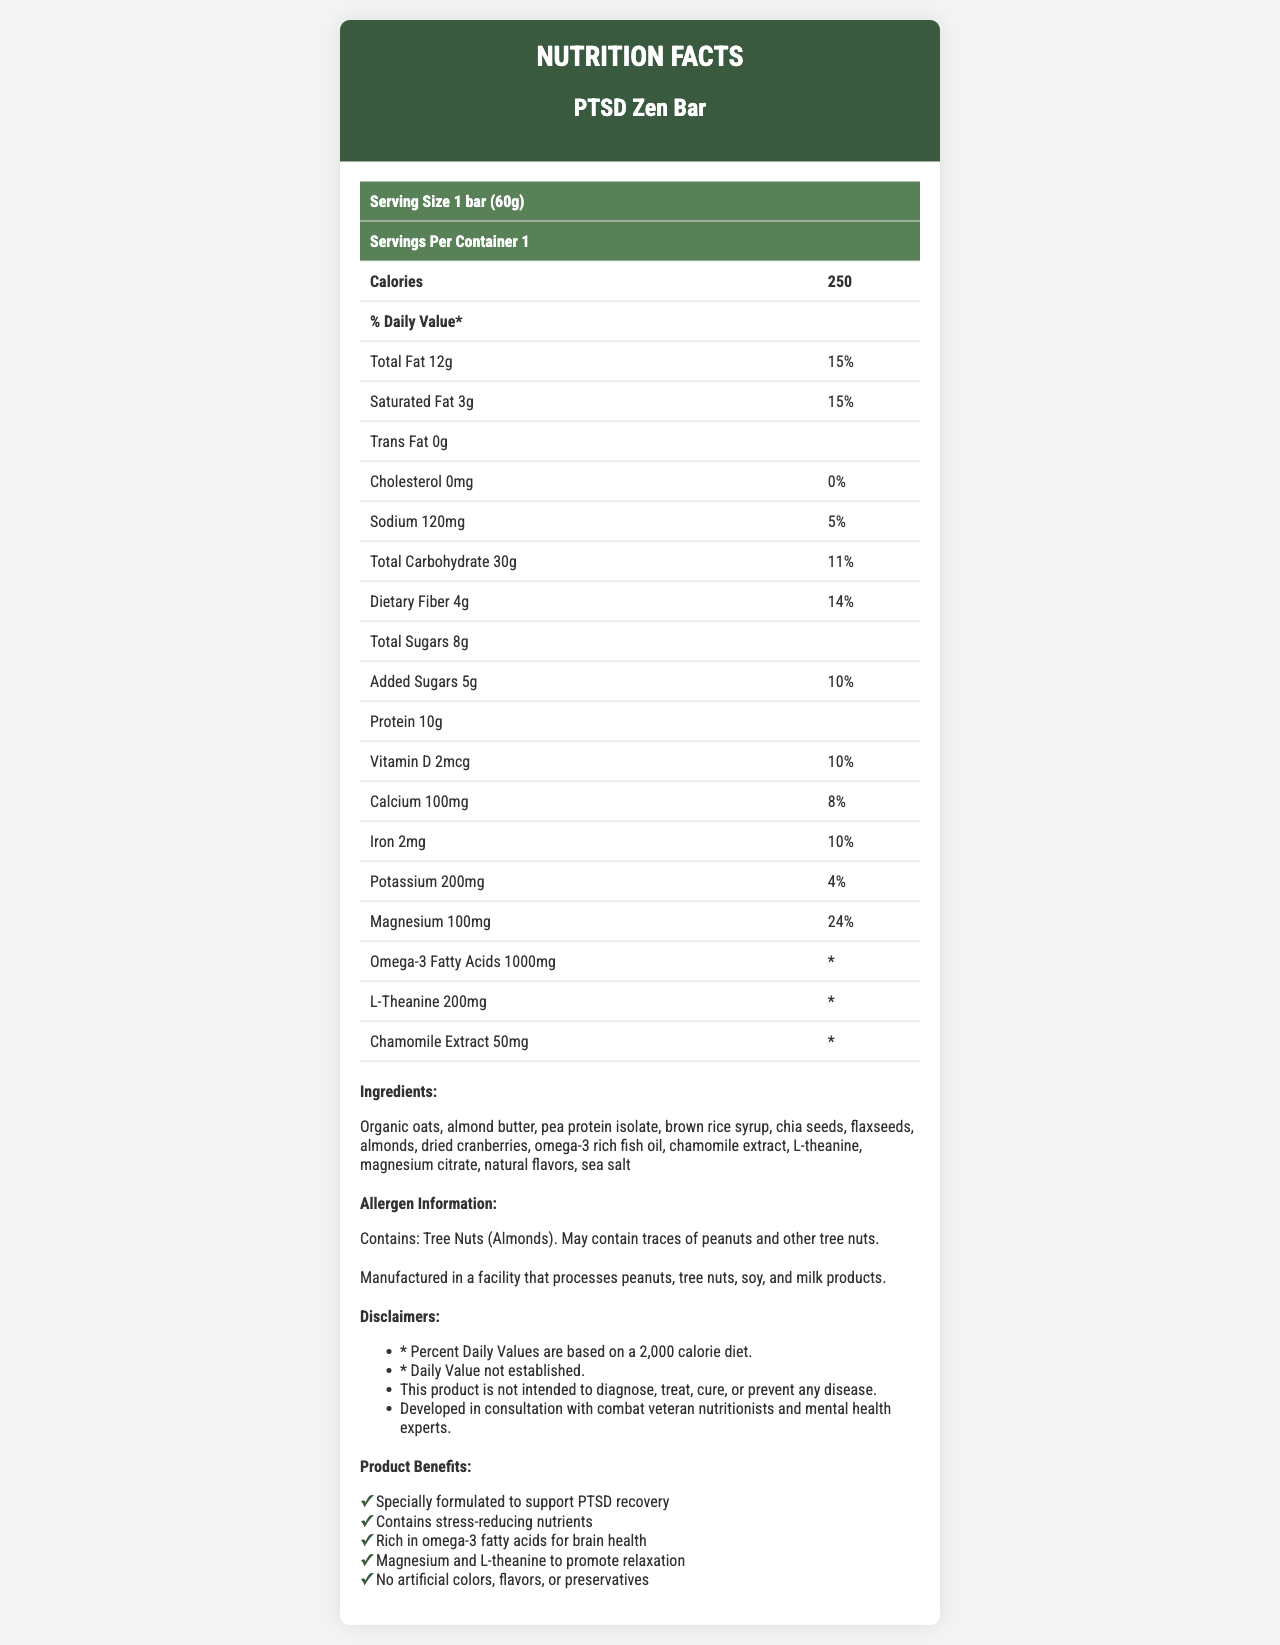what is the serving size of the PTSD Zen Bar? The serving size is explicitly stated as '1 bar (60g)' at the top of the Nutrition Facts table.
Answer: 1 bar (60g) how many calories are in one serving of the PTSD Zen Bar? The number of calories per serving is clearly mentioned as '250' in the document.
Answer: 250 calories which vitamin does the PTSD Zen Bar provide 10% of the daily value? The document lists Vitamin D with an amount of '2mcg', also providing '10%' of the daily value.
Answer: Vitamin D What are the two main ingredients in the PTSD Zen Bar? The ingredients list begins with 'Organic oats, almond butter,' indicating they are the main ingredients.
Answer: Organic oats and almond butter does the PTSD Zen Bar contain any cholesterol? The cholesterol amount is listed as '0mg', with a '0%' daily value, indicating there is no cholesterol in the product.
Answer: No what specific allergens does the PTSD Zen Bar contain? The allergen information explicitly states 'Contains: Tree Nuts (Almonds)'.
Answer: Tree Nuts (Almonds) how much protein is in one serving of the PTSD Zen Bar? The protein content is listed as '10g' in the Nutrition Facts.
Answer: 10g which nutrient is present in the highest quantity relative to its daily value percentage? A. Magnesium B. Calcium C. Iron D. Omega-3 Fatty Acids Magnesium is shown to be at '24%' of the daily value, which is higher than Calcium ('8%') and Iron ('10%'). Omega-3 Fatty Acids do not have a daily value percentage established.
Answer: A. Magnesium which of the following is NOT a benefit claimed by the PTSD Zen Bar? 1) Contains stress-reducing nutrients 2) Promotes General Energy Increase 3) Rich in omega-3 fatty acids for brain health The listed benefits include stress-reducing nutrients and omega-3 fatty acids for brain health, but 'Promotes General Energy Increase' is not mentioned.
Answer: 2) Promotes General Energy Increase Is the PTSD Zen Bar suitable for people with peanut allergies? The document mentions that it 'May contain traces of peanuts', indicating a risk for people with peanut allergies.
Answer: Not necessarily Summarize the main claims and nutritional information of the PTSD Zen Bar. The document includes comprehensive details about the bar's ingredients and nutritional value, marketing it as a product that promotes brain health and relaxation, particularly targeting those recovering from PTSD.
Answer: The PTSD Zen Bar is designed to support PTSD recovery with stress-reducing nutrients and contains organic oats, almond butter, and other beneficial ingredients. It provides 250 calories per serving, with key nutrients like 12g of fat, 30g of carbohydrates, 10g of protein, and significant amounts of magnesium and omega-3 fatty acids. The bar also contains chamomile extract and L-theanine to promote relaxation. How much Omega-3 fatty acids are present in the PTSD Zen Bar? The amount of Omega-3 fatty acids is explicitly listed as '1000mg' in the document.
Answer: 1000mg who were consulted in the development of the PTSD Zen Bar? The manufacturer’s statement confirms that the product was developed in consultation with combat veteran nutritionists and mental health experts.
Answer: Combat veteran nutritionists and mental health experts What is the magnesium content in the PTSD Zen Bar? The document states that the magnesium content is '100mg'.
Answer: 100mg What are the sources of Omega-3 fatty acids in the PTSD Zen Bar? The ingredients list includes 'omega-3 rich fish oil', indicating it as the source of Omega-3 fatty acids.
Answer: Fish oil What benefits are highlighted for the PTSD Zen Bar related to mental health? The marketing claims emphasize the product's support for stress reduction and relaxation, primarily through its inclusion of magnesium and L-theanine.
Answer: Contains stress-reducing nutrients, magnesium, and L-theanine to promote relaxation does this product guarantee the mitigation of PTSD symptoms? The disclaimers clearly state, 'This product is not intended to diagnose, treat, cure, or prevent any disease.'
Answer: No What is the total amount of sugars in the PTSD Zen Bar? The Nutrition Facts list 'Total Sugars' as '8g' and 'Added Sugars' as '5g'.
Answer: 8g (Total Sugars), 5g (Added Sugars) How much sodium does one serving of the PTSD Zen Bar contain? The sodium content is listed as '120mg' with a '5%' daily value.
Answer: 120mg What document information about tree nuts should be verified by individuals with tree nut allergies? The document mentions the product contains almonds and may contain traces of other tree nuts, due to being processed in a facility with such allergens.
Answer: Allergen Information and Manufacturer Statement Which nutrient has a stated value that exceeds 20% of the daily recommended amount? The document lists magnesium with a '24% Daily Value', exceeding 20%.
Answer: Magnesium 